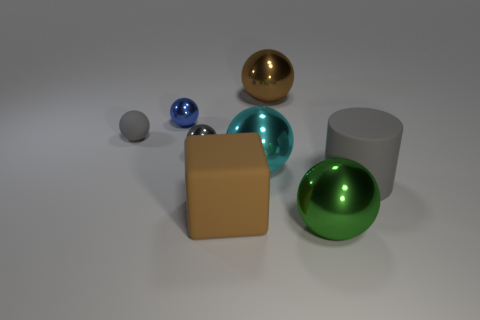Is there a big sphere that has the same material as the green thing?
Ensure brevity in your answer.  Yes. What size is the matte thing that is the same color as the matte ball?
Provide a succinct answer. Large. What is the gray object that is on the right side of the shiny object that is on the right side of the large brown metal object made of?
Provide a succinct answer. Rubber. How many metal balls have the same color as the big cylinder?
Your answer should be compact. 1. There is a green object that is made of the same material as the small blue object; what size is it?
Ensure brevity in your answer.  Large. There is a rubber object that is behind the small gray shiny thing; what is its shape?
Offer a very short reply. Sphere. The other green object that is the same shape as the tiny rubber object is what size?
Your response must be concise. Large. What number of big metal objects are in front of the large green thing left of the gray rubber thing that is to the right of the large block?
Your answer should be very brief. 0. Are there an equal number of big gray cylinders behind the big brown rubber object and objects?
Your answer should be very brief. No. How many cubes are small gray objects or brown metal objects?
Offer a terse response. 0. 